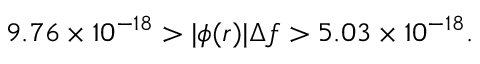<formula> <loc_0><loc_0><loc_500><loc_500>9 . 7 6 \times 1 0 ^ { - 1 8 } > | \phi ( r ) | \Delta f > 5 . 0 3 \times 1 0 ^ { - 1 8 } .</formula> 